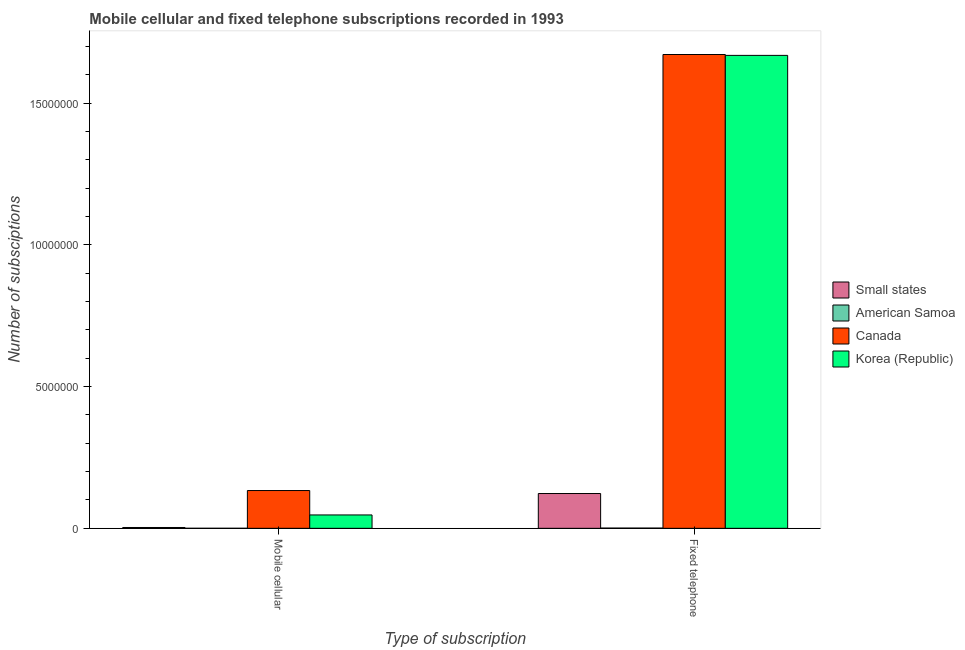How many different coloured bars are there?
Give a very brief answer. 4. How many groups of bars are there?
Offer a very short reply. 2. Are the number of bars per tick equal to the number of legend labels?
Your answer should be very brief. Yes. How many bars are there on the 2nd tick from the left?
Offer a terse response. 4. How many bars are there on the 2nd tick from the right?
Offer a terse response. 4. What is the label of the 1st group of bars from the left?
Your answer should be compact. Mobile cellular. What is the number of fixed telephone subscriptions in Canada?
Make the answer very short. 1.67e+07. Across all countries, what is the maximum number of mobile cellular subscriptions?
Your response must be concise. 1.33e+06. Across all countries, what is the minimum number of fixed telephone subscriptions?
Make the answer very short. 8000. In which country was the number of fixed telephone subscriptions maximum?
Give a very brief answer. Canada. In which country was the number of mobile cellular subscriptions minimum?
Ensure brevity in your answer.  American Samoa. What is the total number of fixed telephone subscriptions in the graph?
Your answer should be compact. 3.46e+07. What is the difference between the number of fixed telephone subscriptions in Korea (Republic) and that in Canada?
Ensure brevity in your answer.  -3.07e+04. What is the difference between the number of fixed telephone subscriptions in Korea (Republic) and the number of mobile cellular subscriptions in American Samoa?
Your answer should be very brief. 1.67e+07. What is the average number of fixed telephone subscriptions per country?
Provide a succinct answer. 8.66e+06. What is the difference between the number of mobile cellular subscriptions and number of fixed telephone subscriptions in Canada?
Offer a very short reply. -1.54e+07. In how many countries, is the number of fixed telephone subscriptions greater than 7000000 ?
Keep it short and to the point. 2. What is the ratio of the number of fixed telephone subscriptions in Canada to that in Small states?
Your response must be concise. 13.62. In how many countries, is the number of fixed telephone subscriptions greater than the average number of fixed telephone subscriptions taken over all countries?
Provide a succinct answer. 2. What does the 1st bar from the left in Mobile cellular represents?
Ensure brevity in your answer.  Small states. What does the 1st bar from the right in Fixed telephone represents?
Your response must be concise. Korea (Republic). How many countries are there in the graph?
Provide a succinct answer. 4. How many legend labels are there?
Ensure brevity in your answer.  4. How are the legend labels stacked?
Your answer should be compact. Vertical. What is the title of the graph?
Your answer should be compact. Mobile cellular and fixed telephone subscriptions recorded in 1993. Does "Pacific island small states" appear as one of the legend labels in the graph?
Keep it short and to the point. No. What is the label or title of the X-axis?
Your response must be concise. Type of subscription. What is the label or title of the Y-axis?
Give a very brief answer. Number of subsciptions. What is the Number of subsciptions in Small states in Mobile cellular?
Offer a terse response. 2.94e+04. What is the Number of subsciptions in American Samoa in Mobile cellular?
Offer a terse response. 900. What is the Number of subsciptions of Canada in Mobile cellular?
Provide a succinct answer. 1.33e+06. What is the Number of subsciptions of Korea (Republic) in Mobile cellular?
Provide a succinct answer. 4.72e+05. What is the Number of subsciptions in Small states in Fixed telephone?
Offer a terse response. 1.23e+06. What is the Number of subsciptions of American Samoa in Fixed telephone?
Keep it short and to the point. 8000. What is the Number of subsciptions in Canada in Fixed telephone?
Provide a succinct answer. 1.67e+07. What is the Number of subsciptions of Korea (Republic) in Fixed telephone?
Your answer should be compact. 1.67e+07. Across all Type of subscription, what is the maximum Number of subsciptions of Small states?
Keep it short and to the point. 1.23e+06. Across all Type of subscription, what is the maximum Number of subsciptions in American Samoa?
Offer a terse response. 8000. Across all Type of subscription, what is the maximum Number of subsciptions in Canada?
Offer a terse response. 1.67e+07. Across all Type of subscription, what is the maximum Number of subsciptions in Korea (Republic)?
Offer a very short reply. 1.67e+07. Across all Type of subscription, what is the minimum Number of subsciptions in Small states?
Make the answer very short. 2.94e+04. Across all Type of subscription, what is the minimum Number of subsciptions in American Samoa?
Give a very brief answer. 900. Across all Type of subscription, what is the minimum Number of subsciptions in Canada?
Ensure brevity in your answer.  1.33e+06. Across all Type of subscription, what is the minimum Number of subsciptions in Korea (Republic)?
Offer a very short reply. 4.72e+05. What is the total Number of subsciptions in Small states in the graph?
Keep it short and to the point. 1.26e+06. What is the total Number of subsciptions of American Samoa in the graph?
Ensure brevity in your answer.  8900. What is the total Number of subsciptions in Canada in the graph?
Offer a very short reply. 1.80e+07. What is the total Number of subsciptions of Korea (Republic) in the graph?
Give a very brief answer. 1.72e+07. What is the difference between the Number of subsciptions in Small states in Mobile cellular and that in Fixed telephone?
Your response must be concise. -1.20e+06. What is the difference between the Number of subsciptions of American Samoa in Mobile cellular and that in Fixed telephone?
Provide a succinct answer. -7100. What is the difference between the Number of subsciptions of Canada in Mobile cellular and that in Fixed telephone?
Offer a terse response. -1.54e+07. What is the difference between the Number of subsciptions in Korea (Republic) in Mobile cellular and that in Fixed telephone?
Your answer should be very brief. -1.62e+07. What is the difference between the Number of subsciptions in Small states in Mobile cellular and the Number of subsciptions in American Samoa in Fixed telephone?
Keep it short and to the point. 2.14e+04. What is the difference between the Number of subsciptions of Small states in Mobile cellular and the Number of subsciptions of Canada in Fixed telephone?
Offer a very short reply. -1.67e+07. What is the difference between the Number of subsciptions in Small states in Mobile cellular and the Number of subsciptions in Korea (Republic) in Fixed telephone?
Your response must be concise. -1.67e+07. What is the difference between the Number of subsciptions in American Samoa in Mobile cellular and the Number of subsciptions in Canada in Fixed telephone?
Make the answer very short. -1.67e+07. What is the difference between the Number of subsciptions of American Samoa in Mobile cellular and the Number of subsciptions of Korea (Republic) in Fixed telephone?
Ensure brevity in your answer.  -1.67e+07. What is the difference between the Number of subsciptions in Canada in Mobile cellular and the Number of subsciptions in Korea (Republic) in Fixed telephone?
Your answer should be very brief. -1.54e+07. What is the average Number of subsciptions in Small states per Type of subscription?
Offer a very short reply. 6.29e+05. What is the average Number of subsciptions in American Samoa per Type of subscription?
Keep it short and to the point. 4450. What is the average Number of subsciptions of Canada per Type of subscription?
Your answer should be compact. 9.02e+06. What is the average Number of subsciptions in Korea (Republic) per Type of subscription?
Your answer should be compact. 8.58e+06. What is the difference between the Number of subsciptions of Small states and Number of subsciptions of American Samoa in Mobile cellular?
Provide a succinct answer. 2.85e+04. What is the difference between the Number of subsciptions in Small states and Number of subsciptions in Canada in Mobile cellular?
Offer a terse response. -1.30e+06. What is the difference between the Number of subsciptions of Small states and Number of subsciptions of Korea (Republic) in Mobile cellular?
Give a very brief answer. -4.42e+05. What is the difference between the Number of subsciptions of American Samoa and Number of subsciptions of Canada in Mobile cellular?
Your answer should be compact. -1.33e+06. What is the difference between the Number of subsciptions in American Samoa and Number of subsciptions in Korea (Republic) in Mobile cellular?
Provide a short and direct response. -4.71e+05. What is the difference between the Number of subsciptions in Canada and Number of subsciptions in Korea (Republic) in Mobile cellular?
Ensure brevity in your answer.  8.61e+05. What is the difference between the Number of subsciptions in Small states and Number of subsciptions in American Samoa in Fixed telephone?
Your answer should be very brief. 1.22e+06. What is the difference between the Number of subsciptions in Small states and Number of subsciptions in Canada in Fixed telephone?
Your answer should be compact. -1.55e+07. What is the difference between the Number of subsciptions in Small states and Number of subsciptions in Korea (Republic) in Fixed telephone?
Your answer should be compact. -1.55e+07. What is the difference between the Number of subsciptions in American Samoa and Number of subsciptions in Canada in Fixed telephone?
Give a very brief answer. -1.67e+07. What is the difference between the Number of subsciptions of American Samoa and Number of subsciptions of Korea (Republic) in Fixed telephone?
Your response must be concise. -1.67e+07. What is the difference between the Number of subsciptions of Canada and Number of subsciptions of Korea (Republic) in Fixed telephone?
Give a very brief answer. 3.07e+04. What is the ratio of the Number of subsciptions of Small states in Mobile cellular to that in Fixed telephone?
Ensure brevity in your answer.  0.02. What is the ratio of the Number of subsciptions in American Samoa in Mobile cellular to that in Fixed telephone?
Offer a terse response. 0.11. What is the ratio of the Number of subsciptions in Canada in Mobile cellular to that in Fixed telephone?
Keep it short and to the point. 0.08. What is the ratio of the Number of subsciptions in Korea (Republic) in Mobile cellular to that in Fixed telephone?
Your response must be concise. 0.03. What is the difference between the highest and the second highest Number of subsciptions in Small states?
Make the answer very short. 1.20e+06. What is the difference between the highest and the second highest Number of subsciptions of American Samoa?
Your answer should be very brief. 7100. What is the difference between the highest and the second highest Number of subsciptions in Canada?
Give a very brief answer. 1.54e+07. What is the difference between the highest and the second highest Number of subsciptions of Korea (Republic)?
Provide a short and direct response. 1.62e+07. What is the difference between the highest and the lowest Number of subsciptions in Small states?
Provide a succinct answer. 1.20e+06. What is the difference between the highest and the lowest Number of subsciptions of American Samoa?
Your answer should be compact. 7100. What is the difference between the highest and the lowest Number of subsciptions in Canada?
Offer a terse response. 1.54e+07. What is the difference between the highest and the lowest Number of subsciptions of Korea (Republic)?
Your response must be concise. 1.62e+07. 